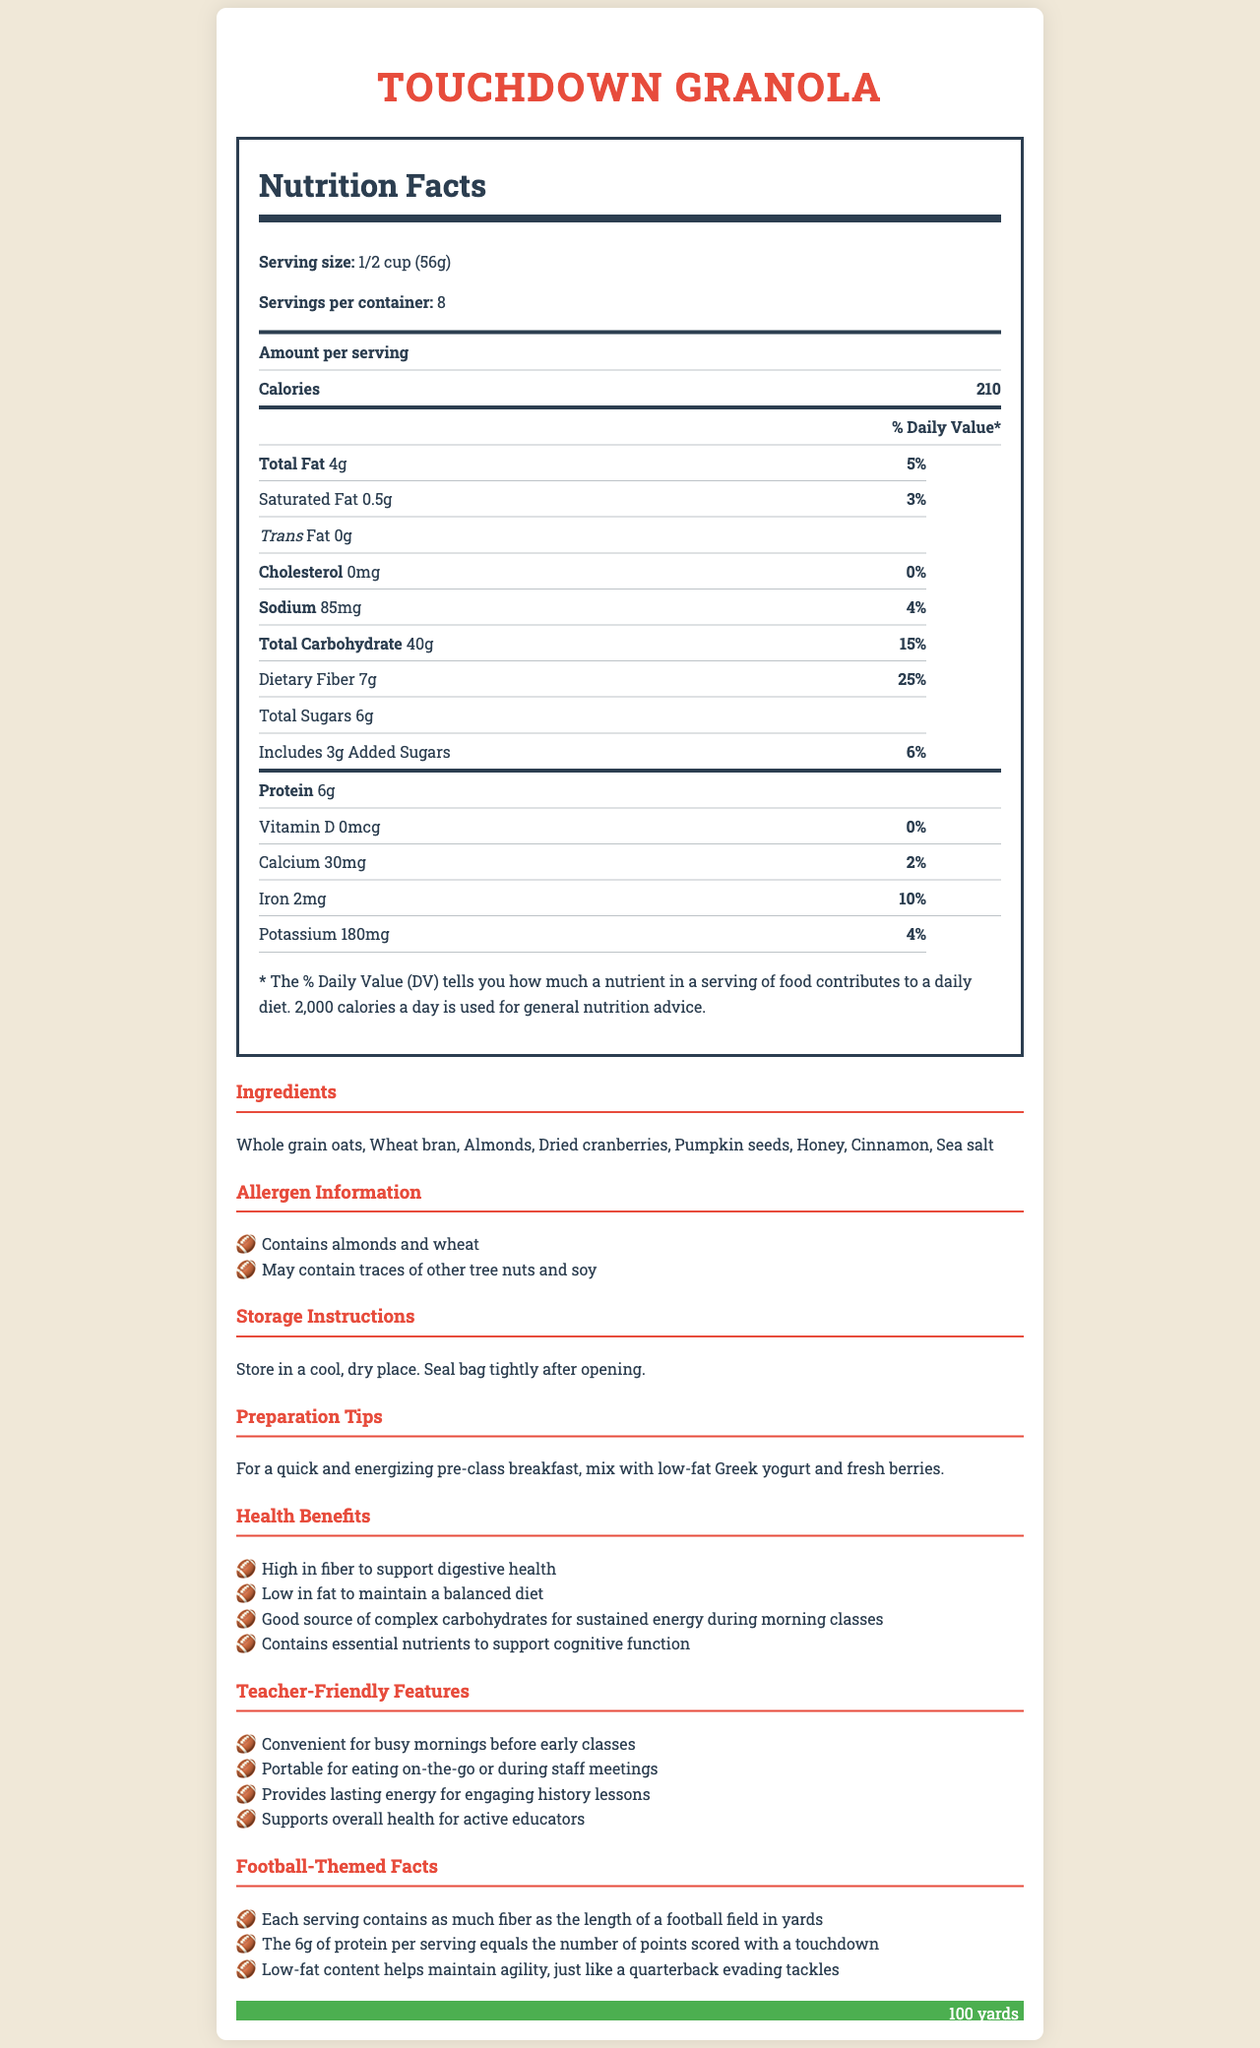What is the serving size of Touchdown Granola? The serving size is explicitly stated as "1/2 cup (56g)" in the nutrition label.
Answer: 1/2 cup (56g) How many calories are there per serving of Touchdown Granola? The value "210" is listed next to "Calories" under the nutrition facts.
Answer: 210 What is the total amount of dietary fiber in one serving? The document states that there are 7 grams of dietary fiber in one serving.
Answer: 7g What allergens are present in Touchdown Granola? The allergens section in the document mentions "Contains almonds and wheat".
Answer: Contains almonds and wheat What is the preparation tip for a quick and energizing pre-class breakfast? The preparation tips suggest mixing with low-fat Greek yogurt and fresh berries.
Answer: Mix with low-fat Greek yogurt and fresh berries Which ingredient is not listed for Touchdown Granola? A. Whole grain oats B. Honey C. Soy D. Wheat bran The ingredients list does not include soy, but it does include whole grain oats, honey, and wheat bran.
Answer: C How much protein does each serving of Touchdown Granola provide? The nutrition label states that each serving provides 6 grams of protein.
Answer: 6g Is there any cholesterol in Touchdown Granola? The document indicates cholesterol as "0mg," meaning there is no cholesterol in this granola.
Answer: No What percentage of the daily value for iron does one serving of Touchdown Granola meet? The nutrition label states that one serving meets 10% of the daily value for iron.
Answer: 10% What is one health benefit mentioned for Touchdown Granola? One health benefit listed is that the granola is "High in fiber to support digestive health".
Answer: High in fiber to support digestive health Which statement is true about the protein content in Touchdown Granola? A. It has more protein than a touchdown is worth in points. B. It has the same amount of protein as the number of points scored with a touchdown. C. It has less protein than a safety is worth in points. The document includes a football-themed fact stating the "6g of protein per serving equals the number of points scored with a touchdown."
Answer: B Can the exact number of tree nuts that might be present in the granola be determined from the document? The document mentions that it "May contain traces of other tree nuts and soy," but does not specify an exact number of tree nuts.
Answer: No What are some teacher-friendly features of Touchdown Granola? The document lists several teacher-friendly features: "Convenient for busy mornings before early classes," "Portable for eating on-the-go or during staff meetings," "Provides lasting energy for engaging history lessons," and "Supports overall health for active educators."
Answer: Convenient for busy mornings, portable, provides lasting energy, supports overall health Summarize the main idea of the Touchdown Granola document. The document provides a comprehensive overview of Touchdown Granola, emphasizing its health benefits, nutritional content, and convenience for teachers. It also incorporates engaging football-themed facts to make the information more interesting.
Answer: Touchdown Granola is a low-fat, high-fiber granola designed for a quick and healthy breakfast, especially suitable for teachers with busy mornings. It contains essential nutrients, provides lasting energy, and has convenient features aimed at educators. The document includes detailed nutrition facts, ingredient lists, allergen information, preparation tips, and football-themed fun facts. 